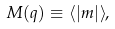Convert formula to latex. <formula><loc_0><loc_0><loc_500><loc_500>M ( q ) \equiv \langle | m | \rangle ,</formula> 